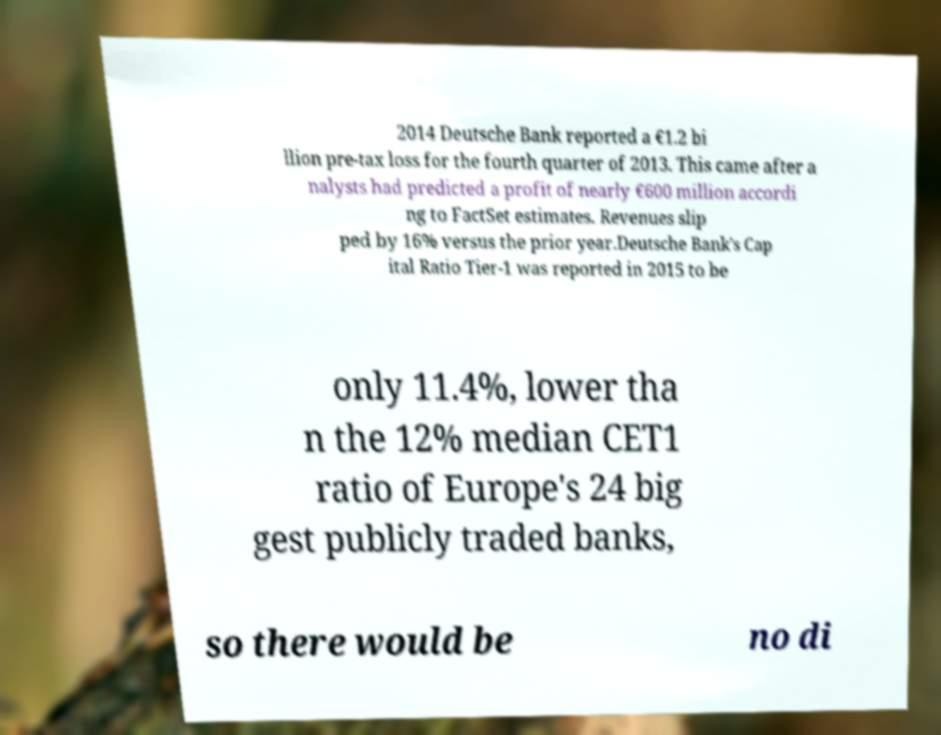There's text embedded in this image that I need extracted. Can you transcribe it verbatim? 2014 Deutsche Bank reported a €1.2 bi llion pre-tax loss for the fourth quarter of 2013. This came after a nalysts had predicted a profit of nearly €600 million accordi ng to FactSet estimates. Revenues slip ped by 16% versus the prior year.Deutsche Bank's Cap ital Ratio Tier-1 was reported in 2015 to be only 11.4%, lower tha n the 12% median CET1 ratio of Europe's 24 big gest publicly traded banks, so there would be no di 